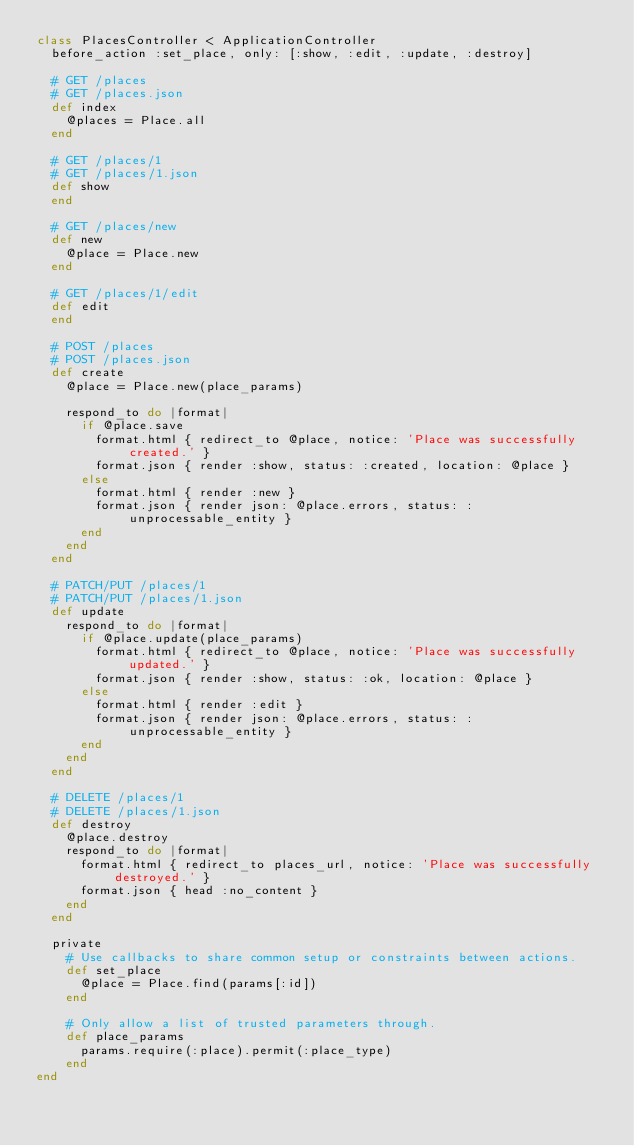<code> <loc_0><loc_0><loc_500><loc_500><_Ruby_>class PlacesController < ApplicationController
  before_action :set_place, only: [:show, :edit, :update, :destroy]

  # GET /places
  # GET /places.json
  def index
    @places = Place.all
  end

  # GET /places/1
  # GET /places/1.json
  def show
  end

  # GET /places/new
  def new
    @place = Place.new
  end

  # GET /places/1/edit
  def edit
  end

  # POST /places
  # POST /places.json
  def create
    @place = Place.new(place_params)

    respond_to do |format|
      if @place.save
        format.html { redirect_to @place, notice: 'Place was successfully created.' }
        format.json { render :show, status: :created, location: @place }
      else
        format.html { render :new }
        format.json { render json: @place.errors, status: :unprocessable_entity }
      end
    end
  end

  # PATCH/PUT /places/1
  # PATCH/PUT /places/1.json
  def update
    respond_to do |format|
      if @place.update(place_params)
        format.html { redirect_to @place, notice: 'Place was successfully updated.' }
        format.json { render :show, status: :ok, location: @place }
      else
        format.html { render :edit }
        format.json { render json: @place.errors, status: :unprocessable_entity }
      end
    end
  end

  # DELETE /places/1
  # DELETE /places/1.json
  def destroy
    @place.destroy
    respond_to do |format|
      format.html { redirect_to places_url, notice: 'Place was successfully destroyed.' }
      format.json { head :no_content }
    end
  end

  private
    # Use callbacks to share common setup or constraints between actions.
    def set_place
      @place = Place.find(params[:id])
    end

    # Only allow a list of trusted parameters through.
    def place_params
      params.require(:place).permit(:place_type)
    end
end
</code> 